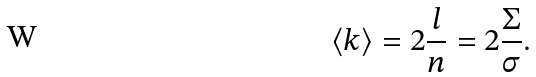<formula> <loc_0><loc_0><loc_500><loc_500>\langle k \rangle = 2 \frac { l } { n } = 2 \frac { \Sigma } { \sigma } .</formula> 